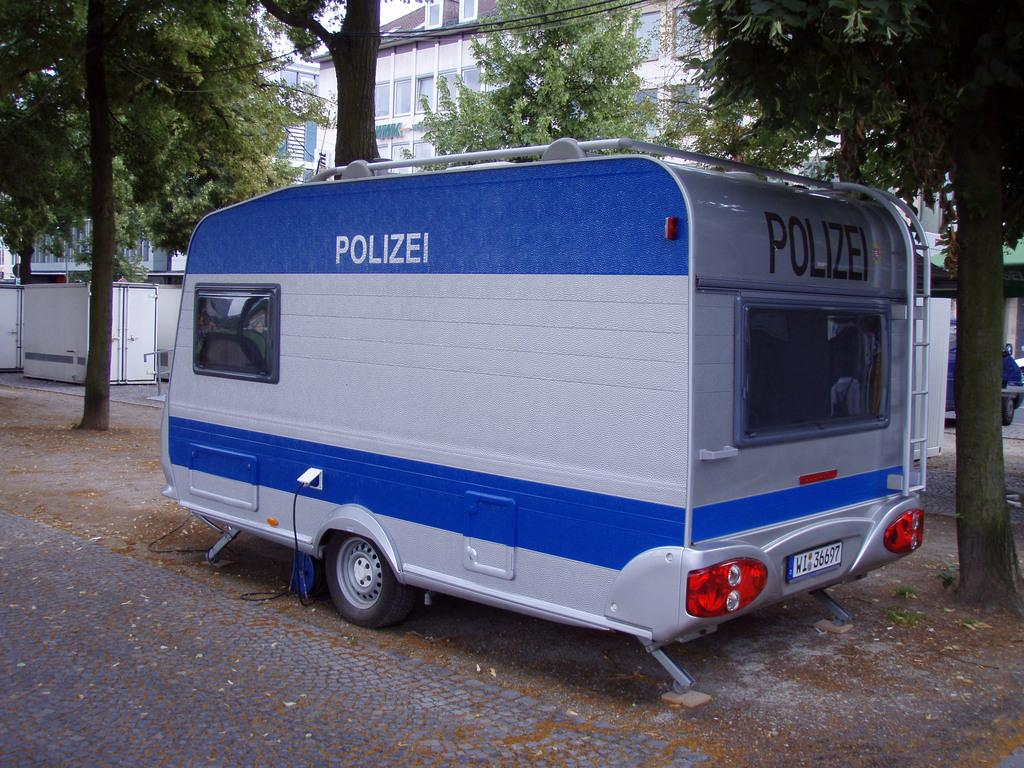What is the main subject in the image? There is a vehicle in the image. What can be seen in the background of the image? There are trees, buildings, and other objects in the background of the image. What is visible at the bottom of the image? The floor is visible at the bottom of the image. What type of news can be heard coming from the vehicle in the image? There is no indication in the image that the vehicle is broadcasting news, so it cannot be determined from the picture. 